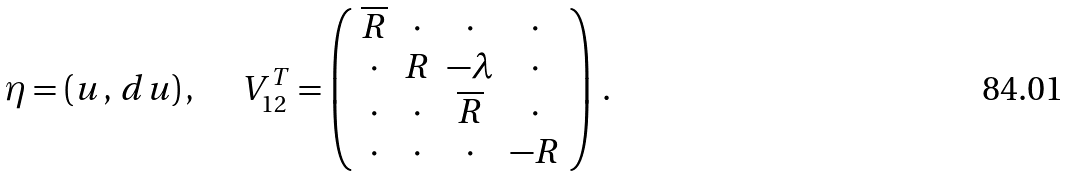Convert formula to latex. <formula><loc_0><loc_0><loc_500><loc_500>\eta = ( u \, , \, d u ) \, , \quad \ V _ { 1 2 } ^ { T } = \left ( \begin{array} { c c c c } \overline { R } & \cdot & \cdot & \cdot \\ \cdot & R & - \lambda & \cdot \\ \cdot & \cdot & \overline { R } & \cdot \\ \cdot & \cdot & \cdot & - R \end{array} \right ) \, .</formula> 